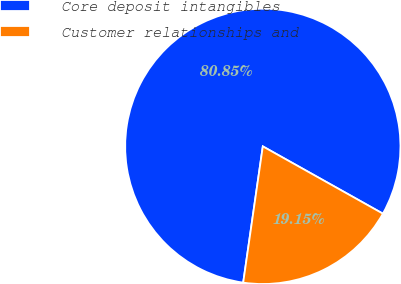Convert chart. <chart><loc_0><loc_0><loc_500><loc_500><pie_chart><fcel>Core deposit intangibles<fcel>Customer relationships and<nl><fcel>80.85%<fcel>19.15%<nl></chart> 